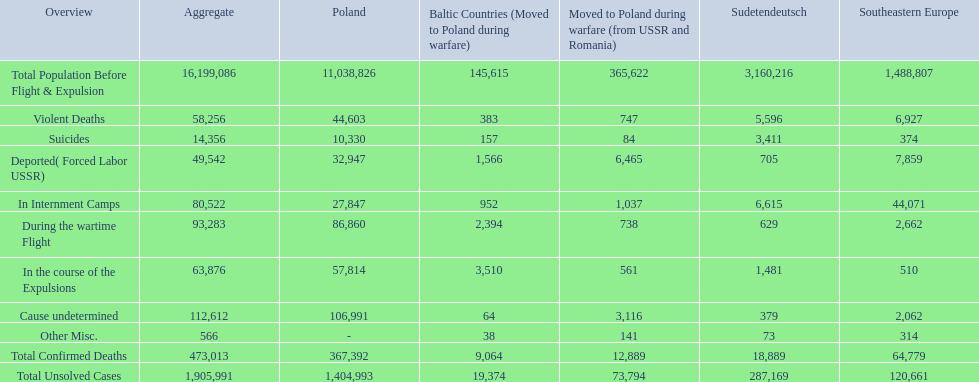What were all of the types of deaths? Violent Deaths, Suicides, Deported( Forced Labor USSR), In Internment Camps, During the wartime Flight, In the course of the Expulsions, Cause undetermined, Other Misc. And their totals in the baltic states? 383, 157, 1,566, 952, 2,394, 3,510, 64, 38. Were more deaths in the baltic states caused by undetermined causes or misc.? Cause undetermined. 